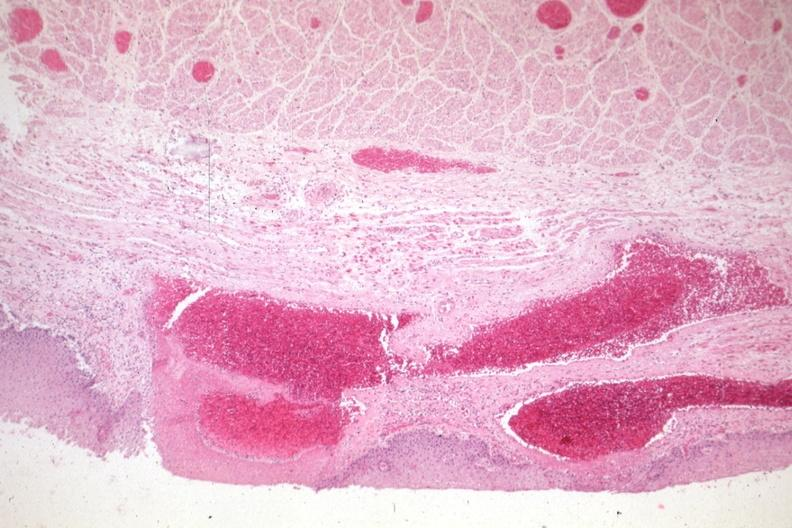where is this from?
Answer the question using a single word or phrase. Gastrointestinal system 